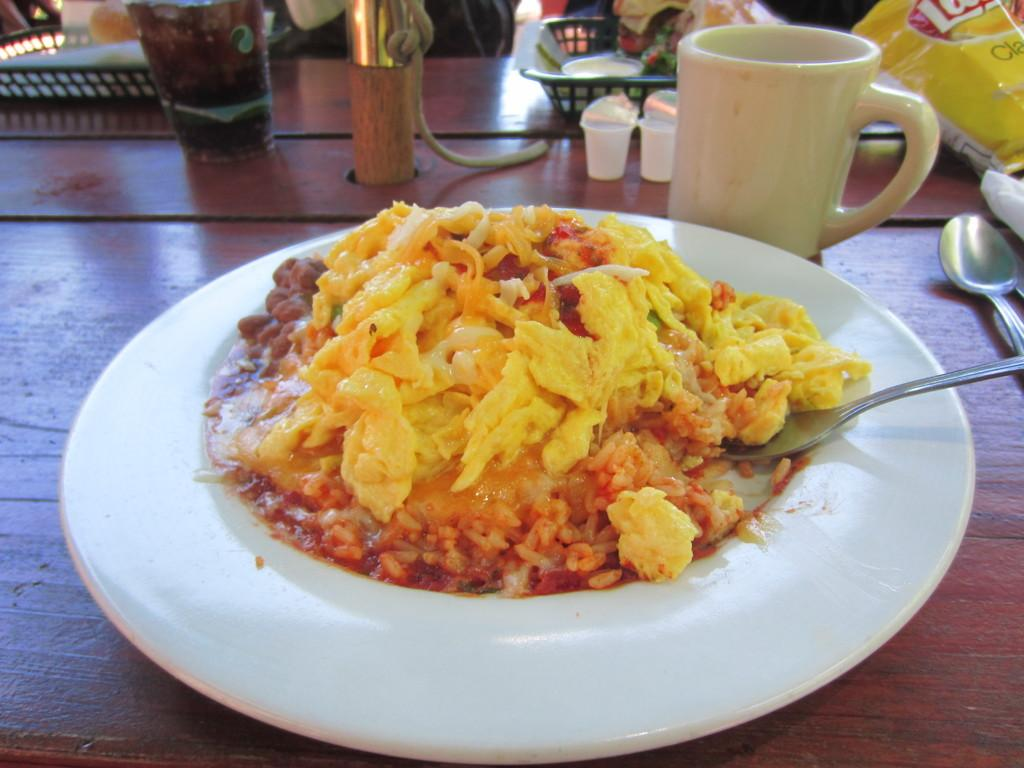What is on the plate that is visible in the image? There is food on a plate in the image. What utensils are visible in the image? There are spoons visible in the image. What type of container is present in the image? There is a cup in the image. What type of packaging is present in the image? There are packets in the image. What type of container is used for holding multiple items in the image? There is a basket in the image. What type of beverage is present in the image? There is a glass with a drink in the image. What other objects can be seen on the table in the image? There are other objects on the table in the image. Is there a kettle connected to the table in the image? There is no kettle present in the image, so it cannot be connected to the table. What advice is given by the food on the plate in the image? The food on the plate does not give any advice, as it is an inanimate object. 